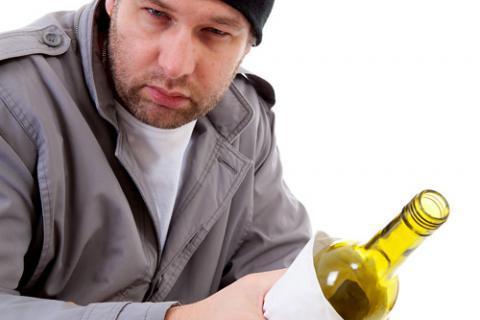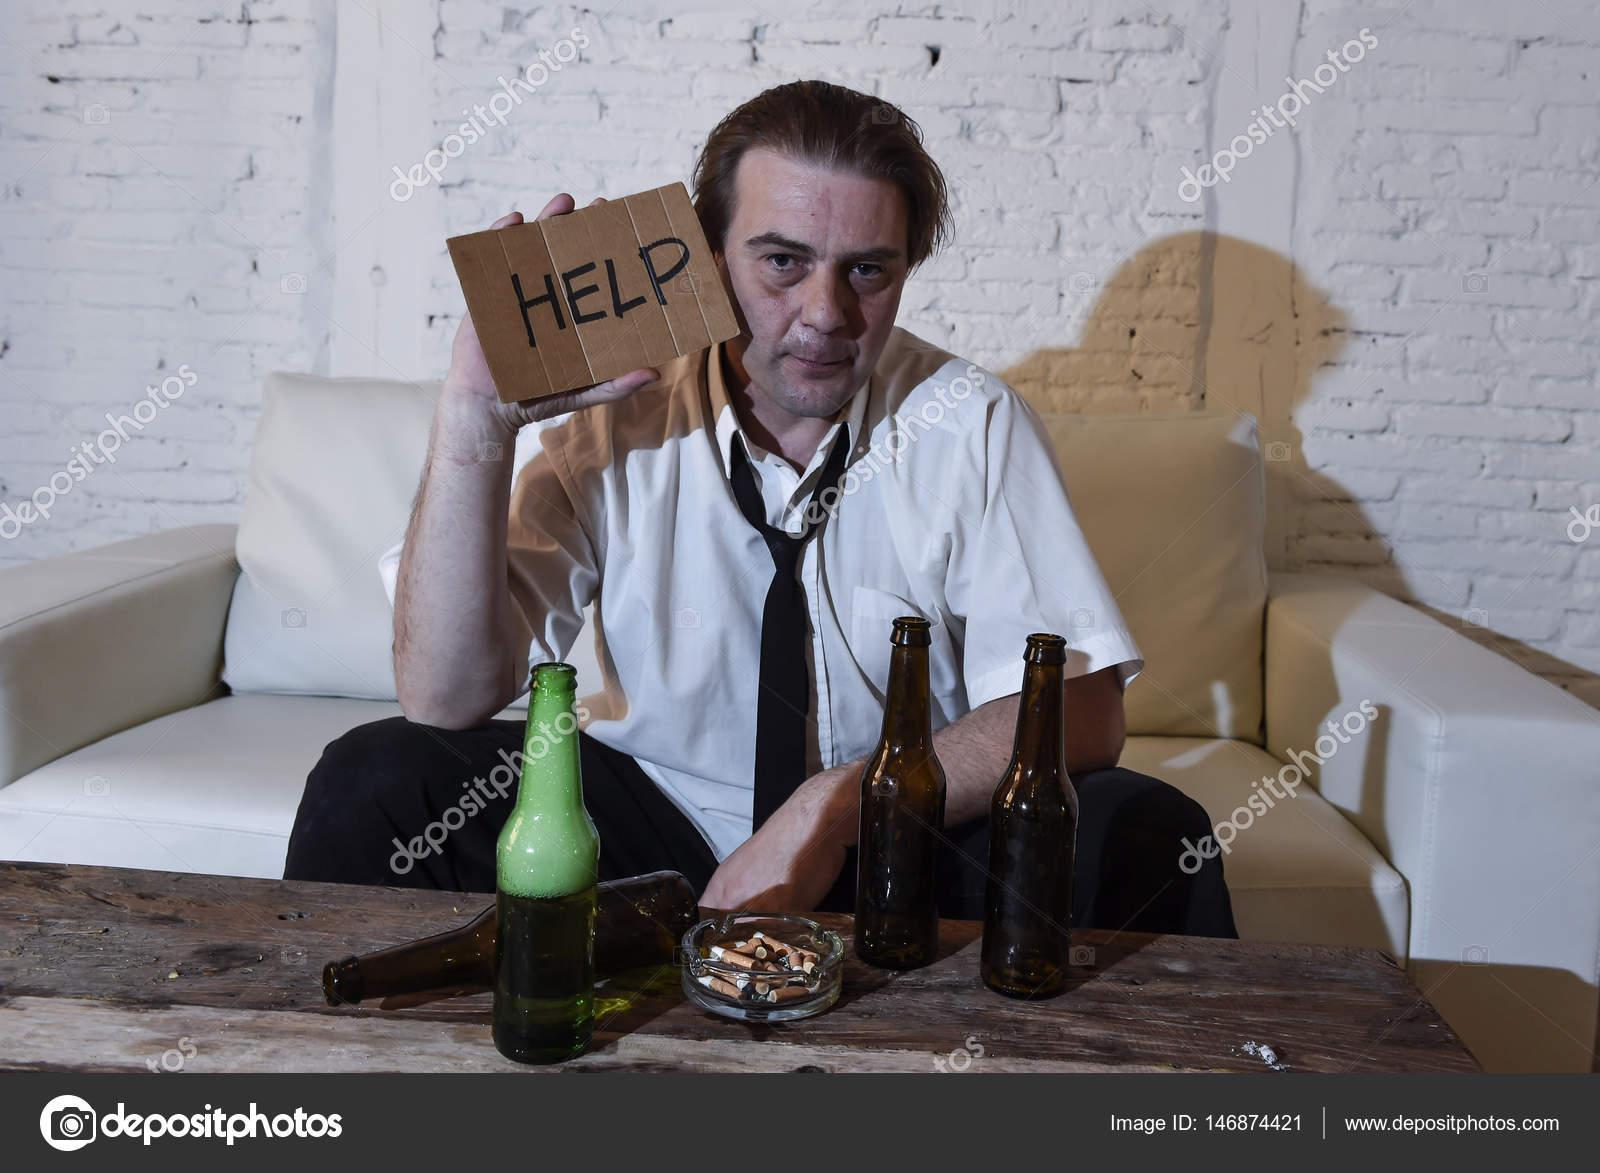The first image is the image on the left, the second image is the image on the right. Considering the images on both sides, is "The left and right image contains the same number of identical men in the same shirts.." valid? Answer yes or no. No. The first image is the image on the left, the second image is the image on the right. Evaluate the accuracy of this statement regarding the images: "The right image shows a man, sitting on a wide white chair behind bottles on a table, wearing a necktie and holding up a cardboard sign.". Is it true? Answer yes or no. Yes. 